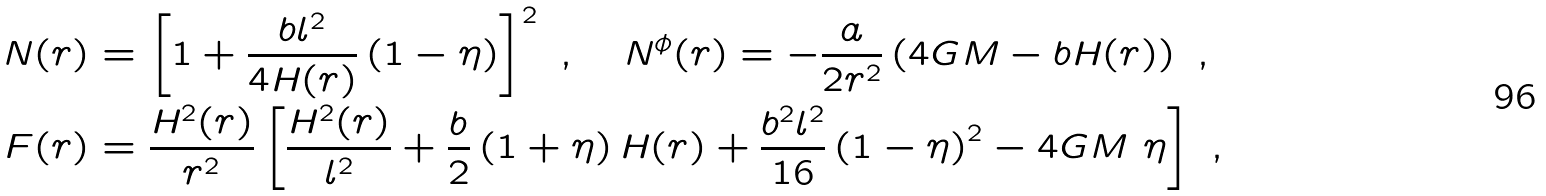<formula> <loc_0><loc_0><loc_500><loc_500>N ( r ) & = \left [ 1 + \frac { b l ^ { 2 } } { 4 H ( r ) } \left ( 1 - \eta \right ) \right ] ^ { 2 } \ , \quad N ^ { \phi } ( r ) = - \frac { a } { 2 r ^ { 2 } } \left ( 4 G M - b H ( r ) \right ) \ , \\ F ( r ) & = \frac { H ^ { 2 } ( r ) } { r ^ { 2 } } \left [ \frac { H ^ { 2 } ( r ) } { l ^ { 2 } } + \frac { b } { 2 } \left ( 1 + \eta \right ) H ( r ) + \frac { b ^ { 2 } l ^ { 2 } } { 1 6 } \left ( 1 - \eta \right ) ^ { 2 } - 4 G M \ \eta \right ] \ ,</formula> 